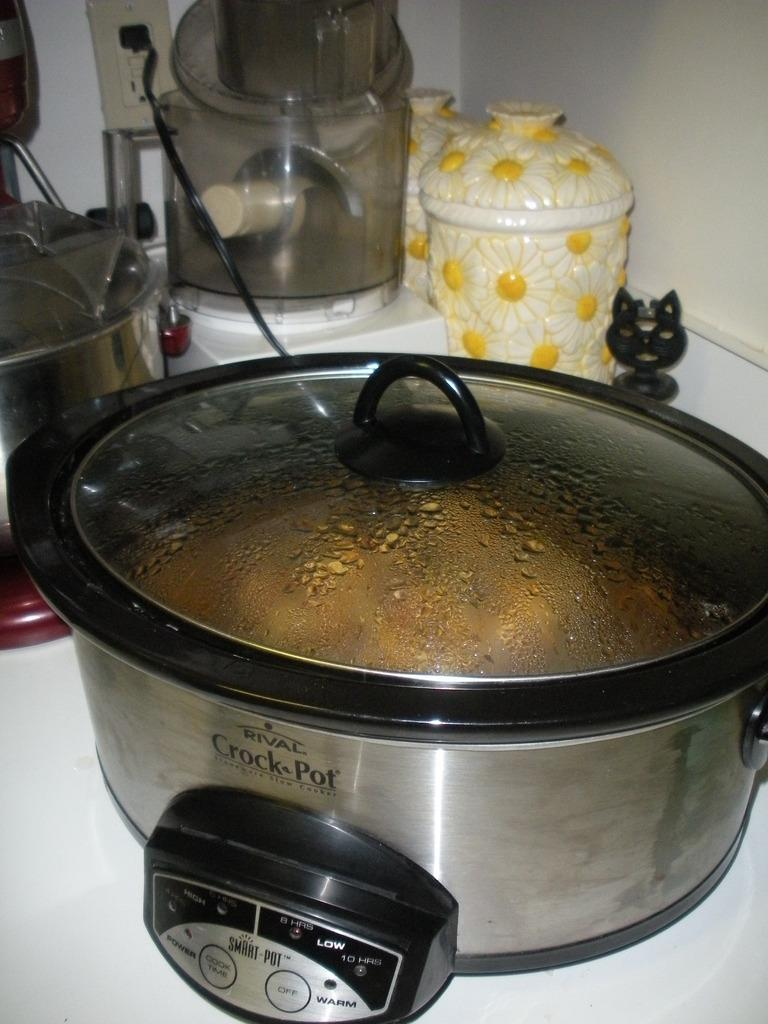<image>
Render a clear and concise summary of the photo. A Rival Crock-Pot is currently in use helping to prepare a meal. 